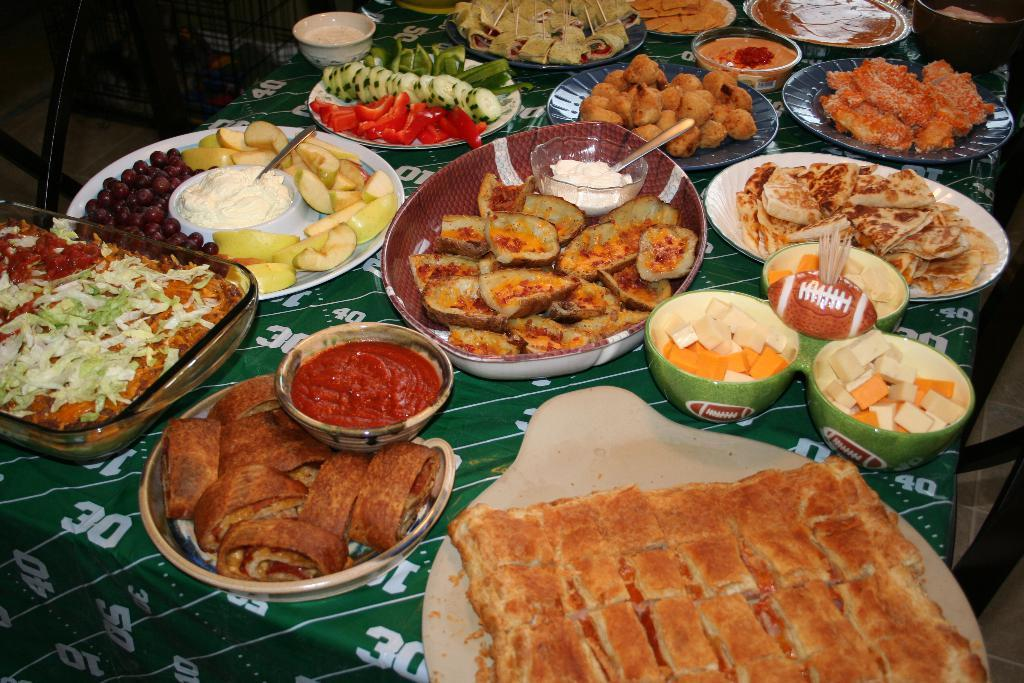What types of food items can be seen in the image? There are food items in plates and bowls in the image. Where are the plates and bowls located? The plates and bowls are placed on a surface that resembles a table. What is covering the table in the image? There is a tablecloth on the table. Can you see any waves in the image? There are no waves present in the image. 